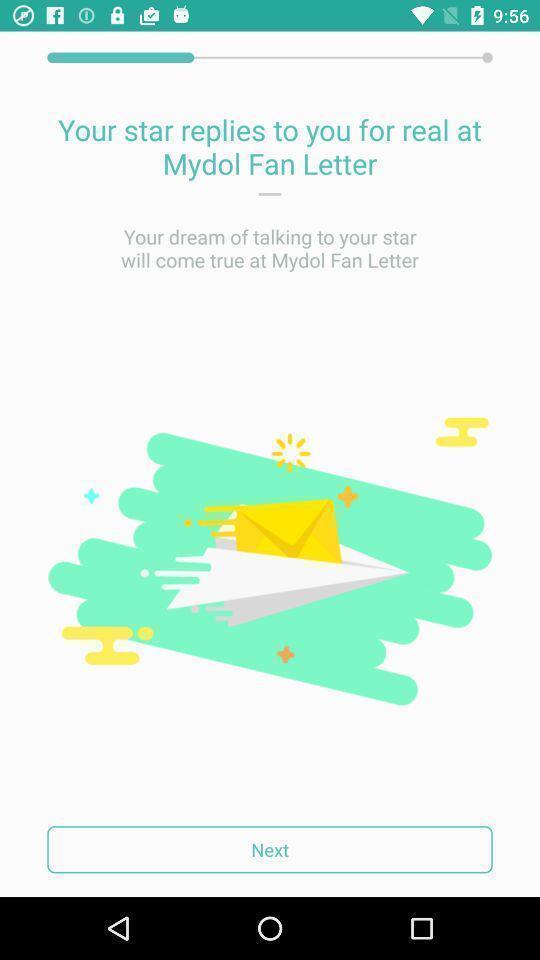Tell me what you see in this picture. Page showing a reply on a chat app. 